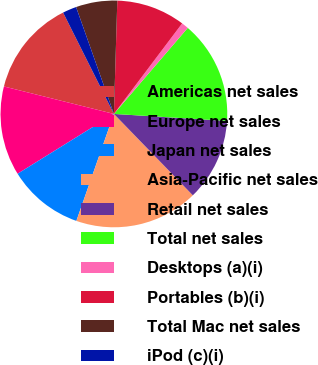<chart> <loc_0><loc_0><loc_500><loc_500><pie_chart><fcel>Americas net sales<fcel>Europe net sales<fcel>Japan net sales<fcel>Asia-Pacific net sales<fcel>Retail net sales<fcel>Total net sales<fcel>Desktops (a)(i)<fcel>Portables (b)(i)<fcel>Total Mac net sales<fcel>iPod (c)(i)<nl><fcel>13.71%<fcel>12.74%<fcel>10.78%<fcel>17.62%<fcel>11.76%<fcel>14.69%<fcel>1.01%<fcel>9.8%<fcel>5.89%<fcel>1.98%<nl></chart> 